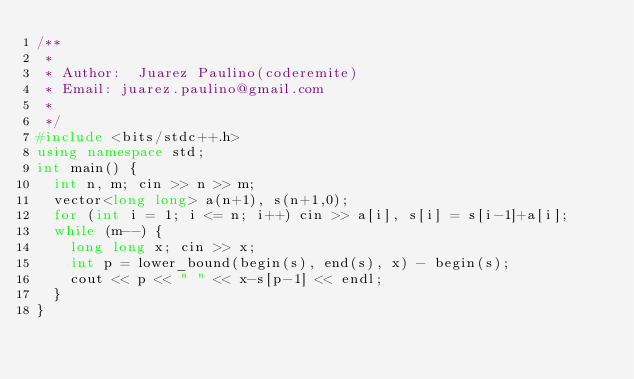<code> <loc_0><loc_0><loc_500><loc_500><_C++_>/**
 *
 * Author:  Juarez Paulino(coderemite)
 * Email: juarez.paulino@gmail.com
 *
 */
#include <bits/stdc++.h>
using namespace std;
int main() {
  int n, m; cin >> n >> m;
  vector<long long> a(n+1), s(n+1,0);
  for (int i = 1; i <= n; i++) cin >> a[i], s[i] = s[i-1]+a[i];
  while (m--) {
    long long x; cin >> x;
    int p = lower_bound(begin(s), end(s), x) - begin(s);
    cout << p << " " << x-s[p-1] << endl;
  }
}
</code> 